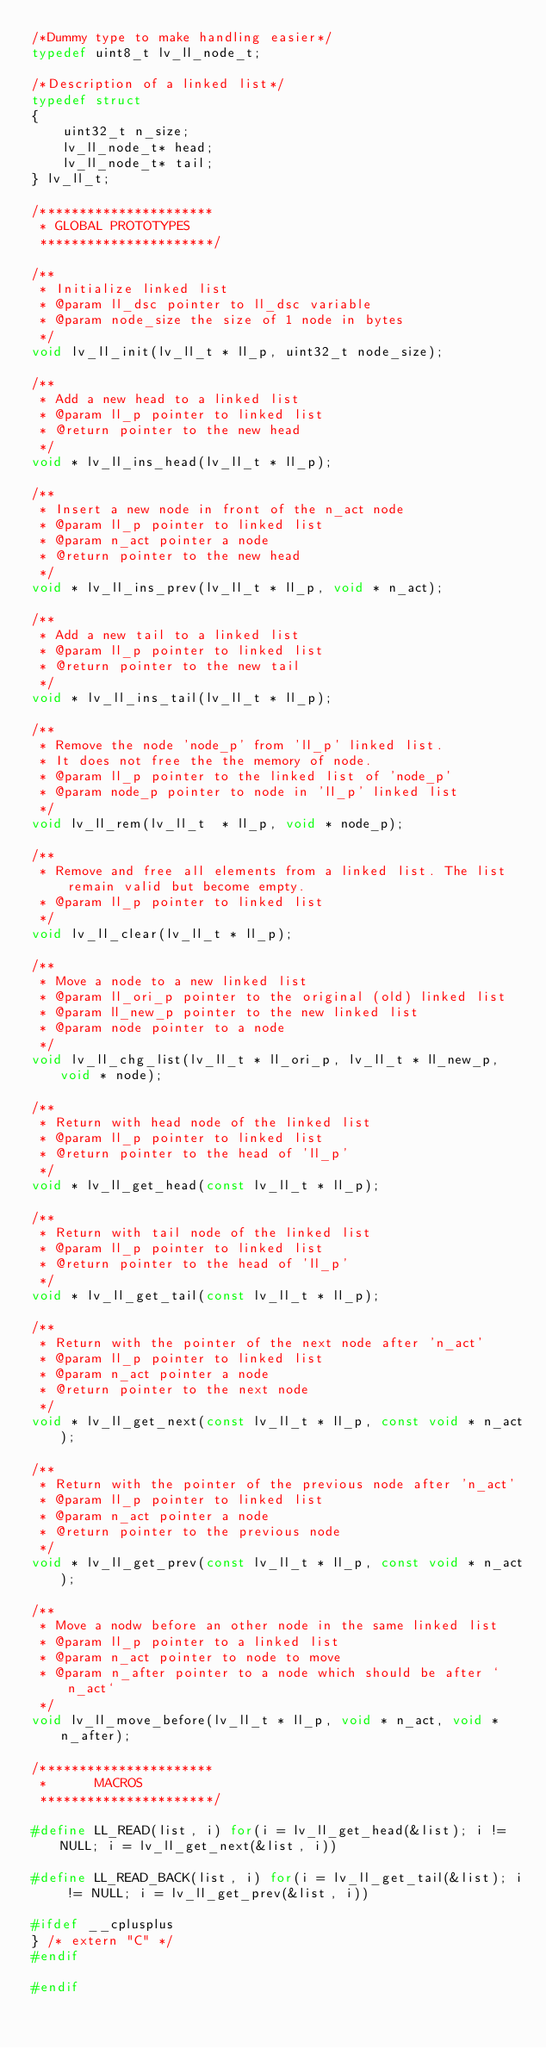<code> <loc_0><loc_0><loc_500><loc_500><_C_>/*Dummy type to make handling easier*/
typedef uint8_t lv_ll_node_t;

/*Description of a linked list*/
typedef struct
{
    uint32_t n_size;
    lv_ll_node_t* head;
    lv_ll_node_t* tail;
} lv_ll_t;

/**********************
 * GLOBAL PROTOTYPES
 **********************/

/**
 * Initialize linked list
 * @param ll_dsc pointer to ll_dsc variable
 * @param node_size the size of 1 node in bytes
 */
void lv_ll_init(lv_ll_t * ll_p, uint32_t node_size);

/**
 * Add a new head to a linked list
 * @param ll_p pointer to linked list
 * @return pointer to the new head
 */
void * lv_ll_ins_head(lv_ll_t * ll_p);

/**
 * Insert a new node in front of the n_act node
 * @param ll_p pointer to linked list
 * @param n_act pointer a node
 * @return pointer to the new head
 */
void * lv_ll_ins_prev(lv_ll_t * ll_p, void * n_act);

/**
 * Add a new tail to a linked list
 * @param ll_p pointer to linked list
 * @return pointer to the new tail
 */
void * lv_ll_ins_tail(lv_ll_t * ll_p);

/**
 * Remove the node 'node_p' from 'll_p' linked list.
 * It does not free the the memory of node.
 * @param ll_p pointer to the linked list of 'node_p'
 * @param node_p pointer to node in 'll_p' linked list
 */
void lv_ll_rem(lv_ll_t  * ll_p, void * node_p);

/**
 * Remove and free all elements from a linked list. The list remain valid but become empty.
 * @param ll_p pointer to linked list
 */
void lv_ll_clear(lv_ll_t * ll_p);

/**
 * Move a node to a new linked list
 * @param ll_ori_p pointer to the original (old) linked list
 * @param ll_new_p pointer to the new linked list
 * @param node pointer to a node
 */
void lv_ll_chg_list(lv_ll_t * ll_ori_p, lv_ll_t * ll_new_p, void * node);

/**
 * Return with head node of the linked list
 * @param ll_p pointer to linked list
 * @return pointer to the head of 'll_p'
 */
void * lv_ll_get_head(const lv_ll_t * ll_p);

/**
 * Return with tail node of the linked list
 * @param ll_p pointer to linked list
 * @return pointer to the head of 'll_p'
 */
void * lv_ll_get_tail(const lv_ll_t * ll_p);

/**
 * Return with the pointer of the next node after 'n_act'
 * @param ll_p pointer to linked list
 * @param n_act pointer a node
 * @return pointer to the next node
 */
void * lv_ll_get_next(const lv_ll_t * ll_p, const void * n_act);

/**
 * Return with the pointer of the previous node after 'n_act'
 * @param ll_p pointer to linked list
 * @param n_act pointer a node
 * @return pointer to the previous node
 */
void * lv_ll_get_prev(const lv_ll_t * ll_p, const void * n_act);

/**
 * Move a nodw before an other node in the same linked list
 * @param ll_p pointer to a linked list
 * @param n_act pointer to node to move
 * @param n_after pointer to a node which should be after `n_act`
 */
void lv_ll_move_before(lv_ll_t * ll_p, void * n_act, void * n_after);

/**********************
 *      MACROS
 **********************/

#define LL_READ(list, i) for(i = lv_ll_get_head(&list); i != NULL; i = lv_ll_get_next(&list, i))

#define LL_READ_BACK(list, i) for(i = lv_ll_get_tail(&list); i != NULL; i = lv_ll_get_prev(&list, i))

#ifdef __cplusplus
} /* extern "C" */
#endif

#endif
</code> 